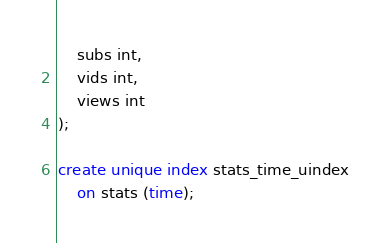Convert code to text. <code><loc_0><loc_0><loc_500><loc_500><_SQL_>	subs int,
	vids int,
	views int
);

create unique index stats_time_uindex
	on stats (time);</code> 